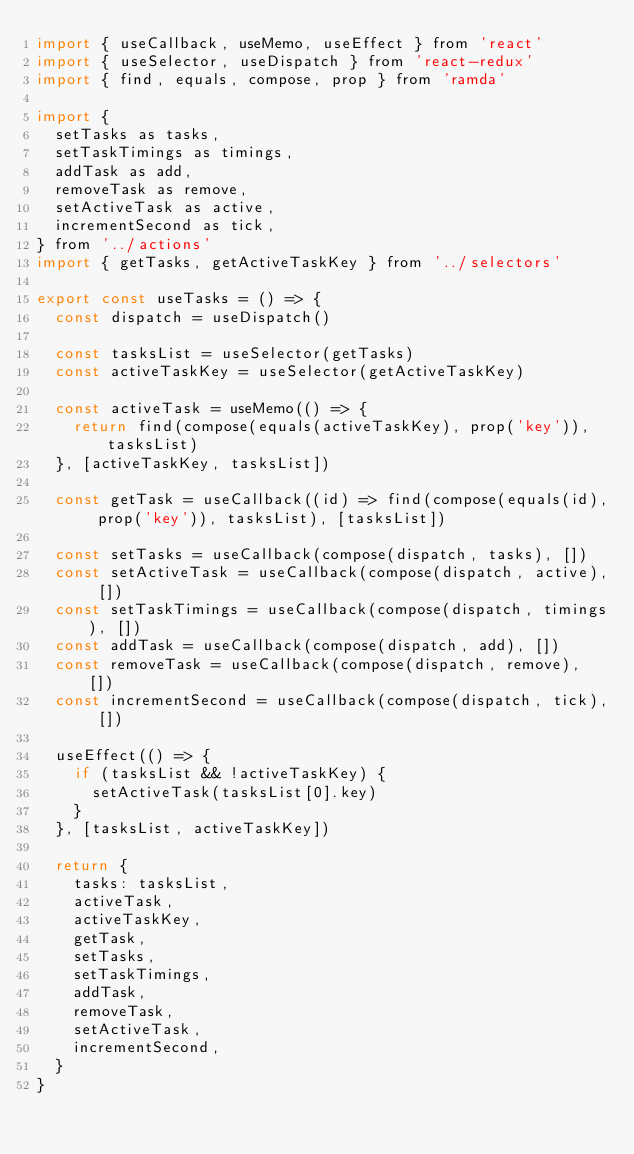<code> <loc_0><loc_0><loc_500><loc_500><_JavaScript_>import { useCallback, useMemo, useEffect } from 'react'
import { useSelector, useDispatch } from 'react-redux'
import { find, equals, compose, prop } from 'ramda'

import {
  setTasks as tasks,
  setTaskTimings as timings,
  addTask as add,
  removeTask as remove,
  setActiveTask as active,
  incrementSecond as tick,
} from '../actions'
import { getTasks, getActiveTaskKey } from '../selectors'

export const useTasks = () => {
  const dispatch = useDispatch()

  const tasksList = useSelector(getTasks)
  const activeTaskKey = useSelector(getActiveTaskKey)

  const activeTask = useMemo(() => {
    return find(compose(equals(activeTaskKey), prop('key')), tasksList)
  }, [activeTaskKey, tasksList])

  const getTask = useCallback((id) => find(compose(equals(id), prop('key')), tasksList), [tasksList])

  const setTasks = useCallback(compose(dispatch, tasks), [])
  const setActiveTask = useCallback(compose(dispatch, active), [])
  const setTaskTimings = useCallback(compose(dispatch, timings), [])
  const addTask = useCallback(compose(dispatch, add), [])
  const removeTask = useCallback(compose(dispatch, remove), [])
  const incrementSecond = useCallback(compose(dispatch, tick), [])

  useEffect(() => {
    if (tasksList && !activeTaskKey) {
      setActiveTask(tasksList[0].key)
    }
  }, [tasksList, activeTaskKey])

  return {
    tasks: tasksList,
    activeTask,
    activeTaskKey,
    getTask,
    setTasks,
    setTaskTimings,
    addTask,
    removeTask,
    setActiveTask,
    incrementSecond,
  }
}
</code> 